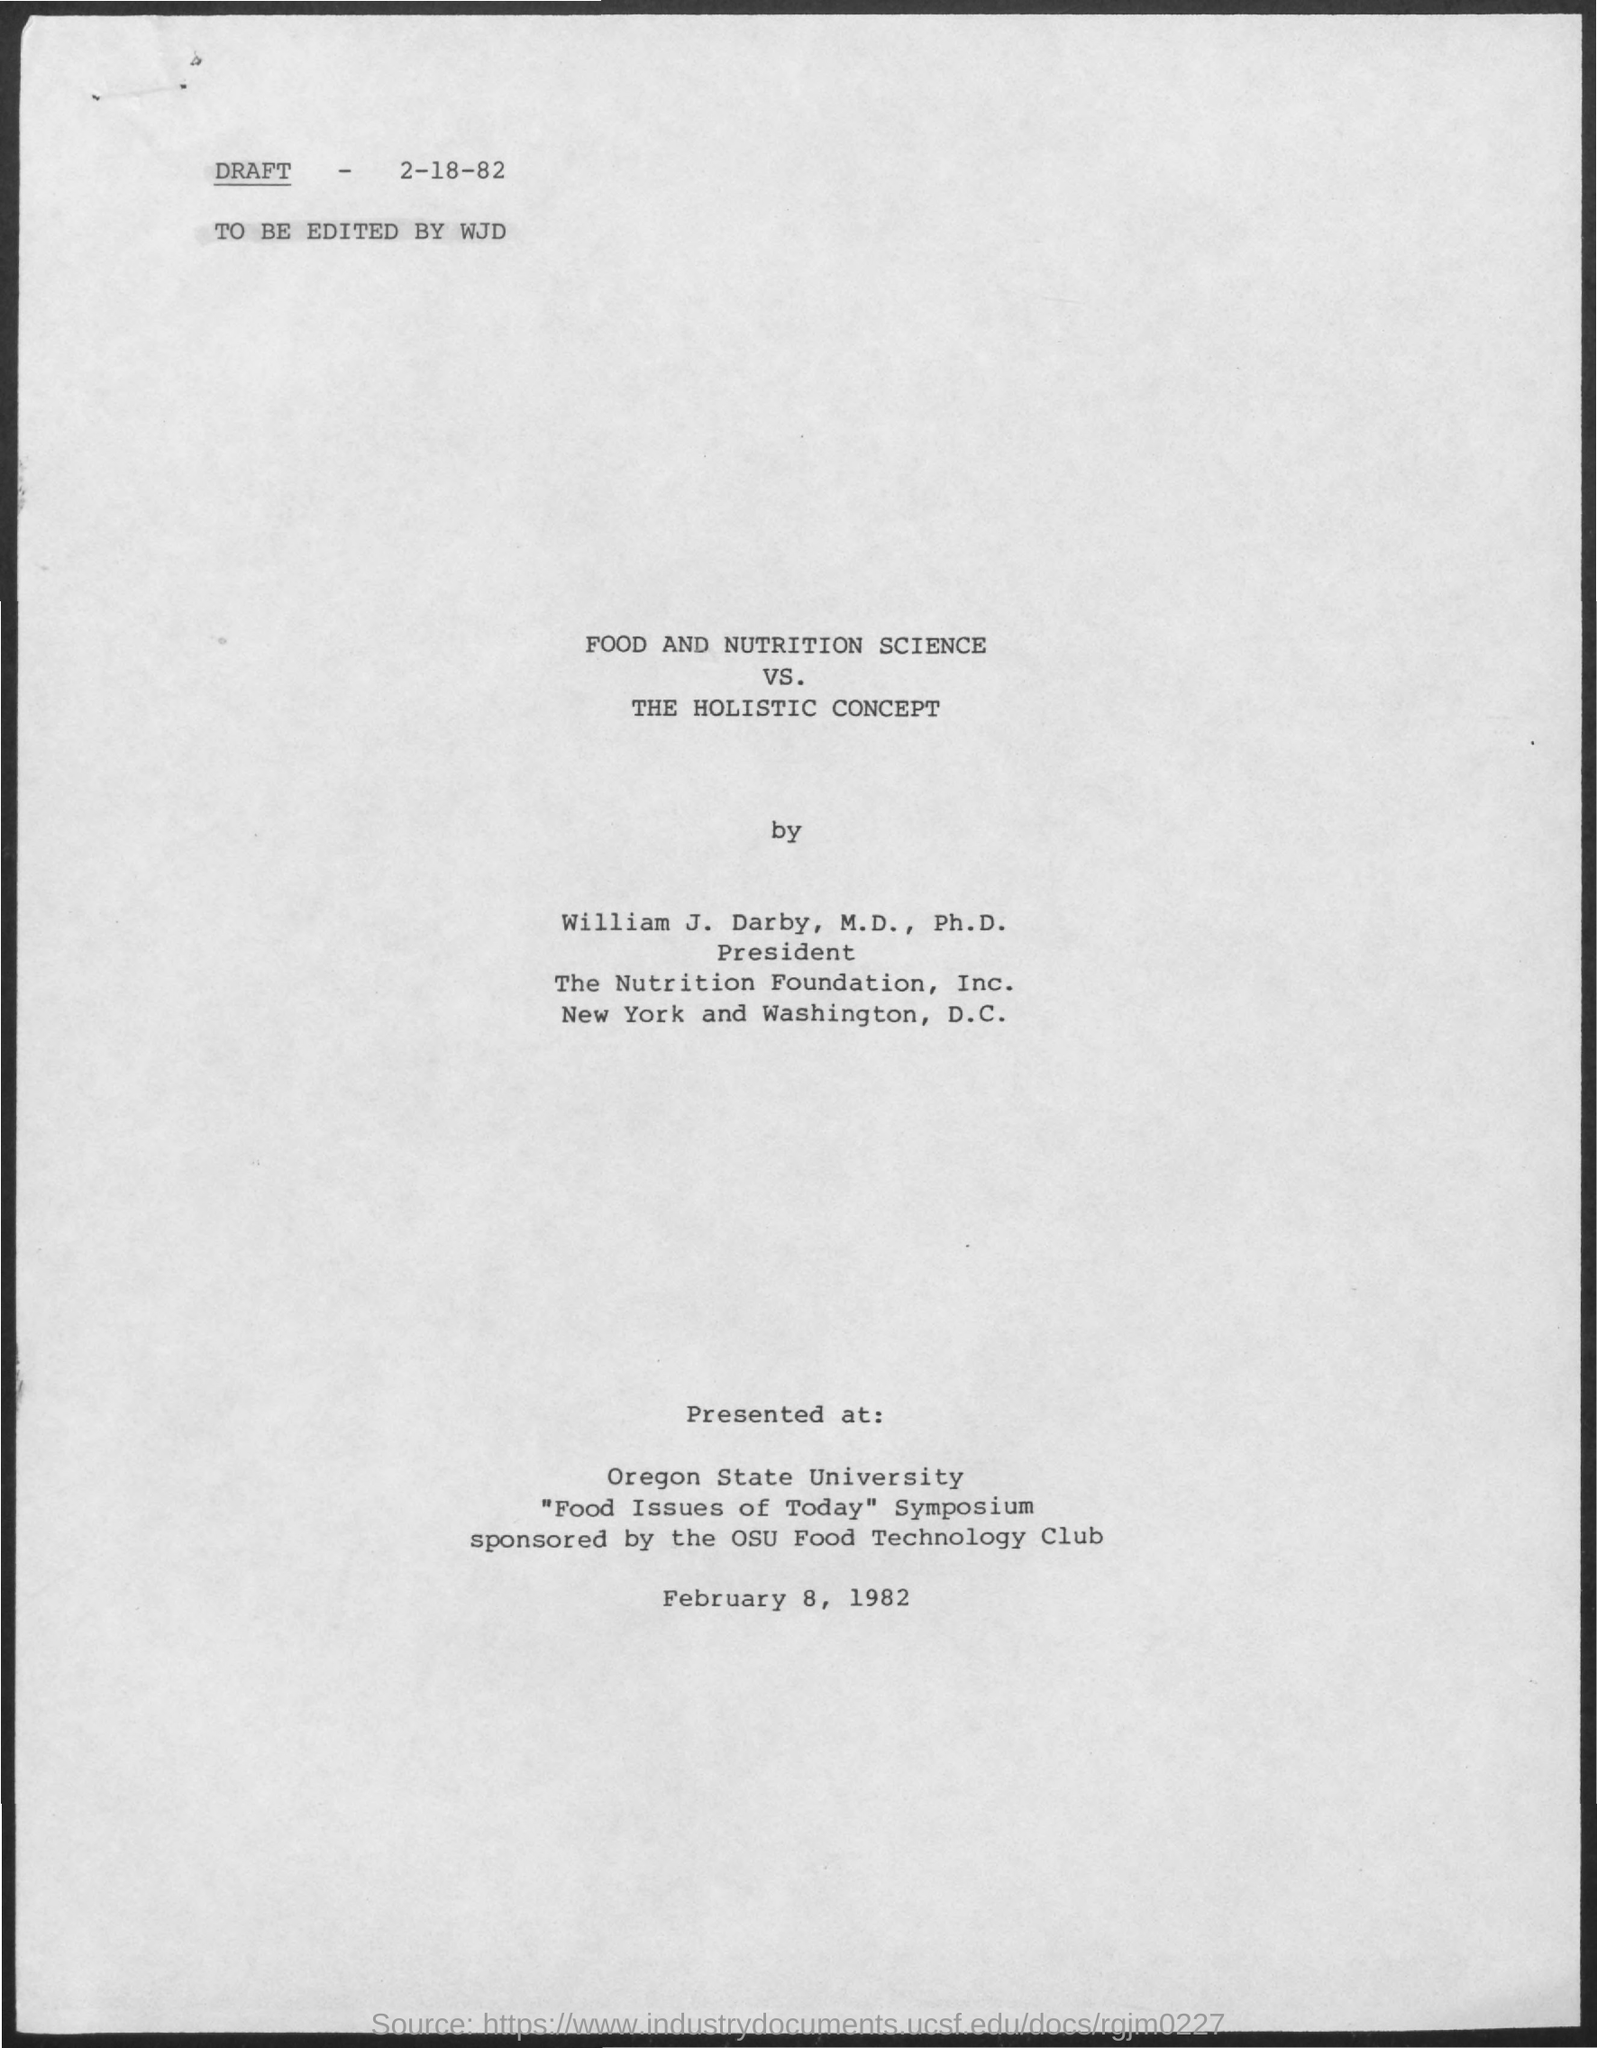Where and when was this document presented? The document was presented at Oregon State University during the 'Food Issues of Today' Symposium sponsored by the OSU Food Technology Club on February 8, 1982. What might be the significance of this presentation? Given the academic setting and the topic, this presentation likely aimed to discuss contemporary food and nutrition issues, and possibly the interplay of scientific approaches versus holistic concepts in nutrition, which could have implications for education, industry practices, and public health policies. 